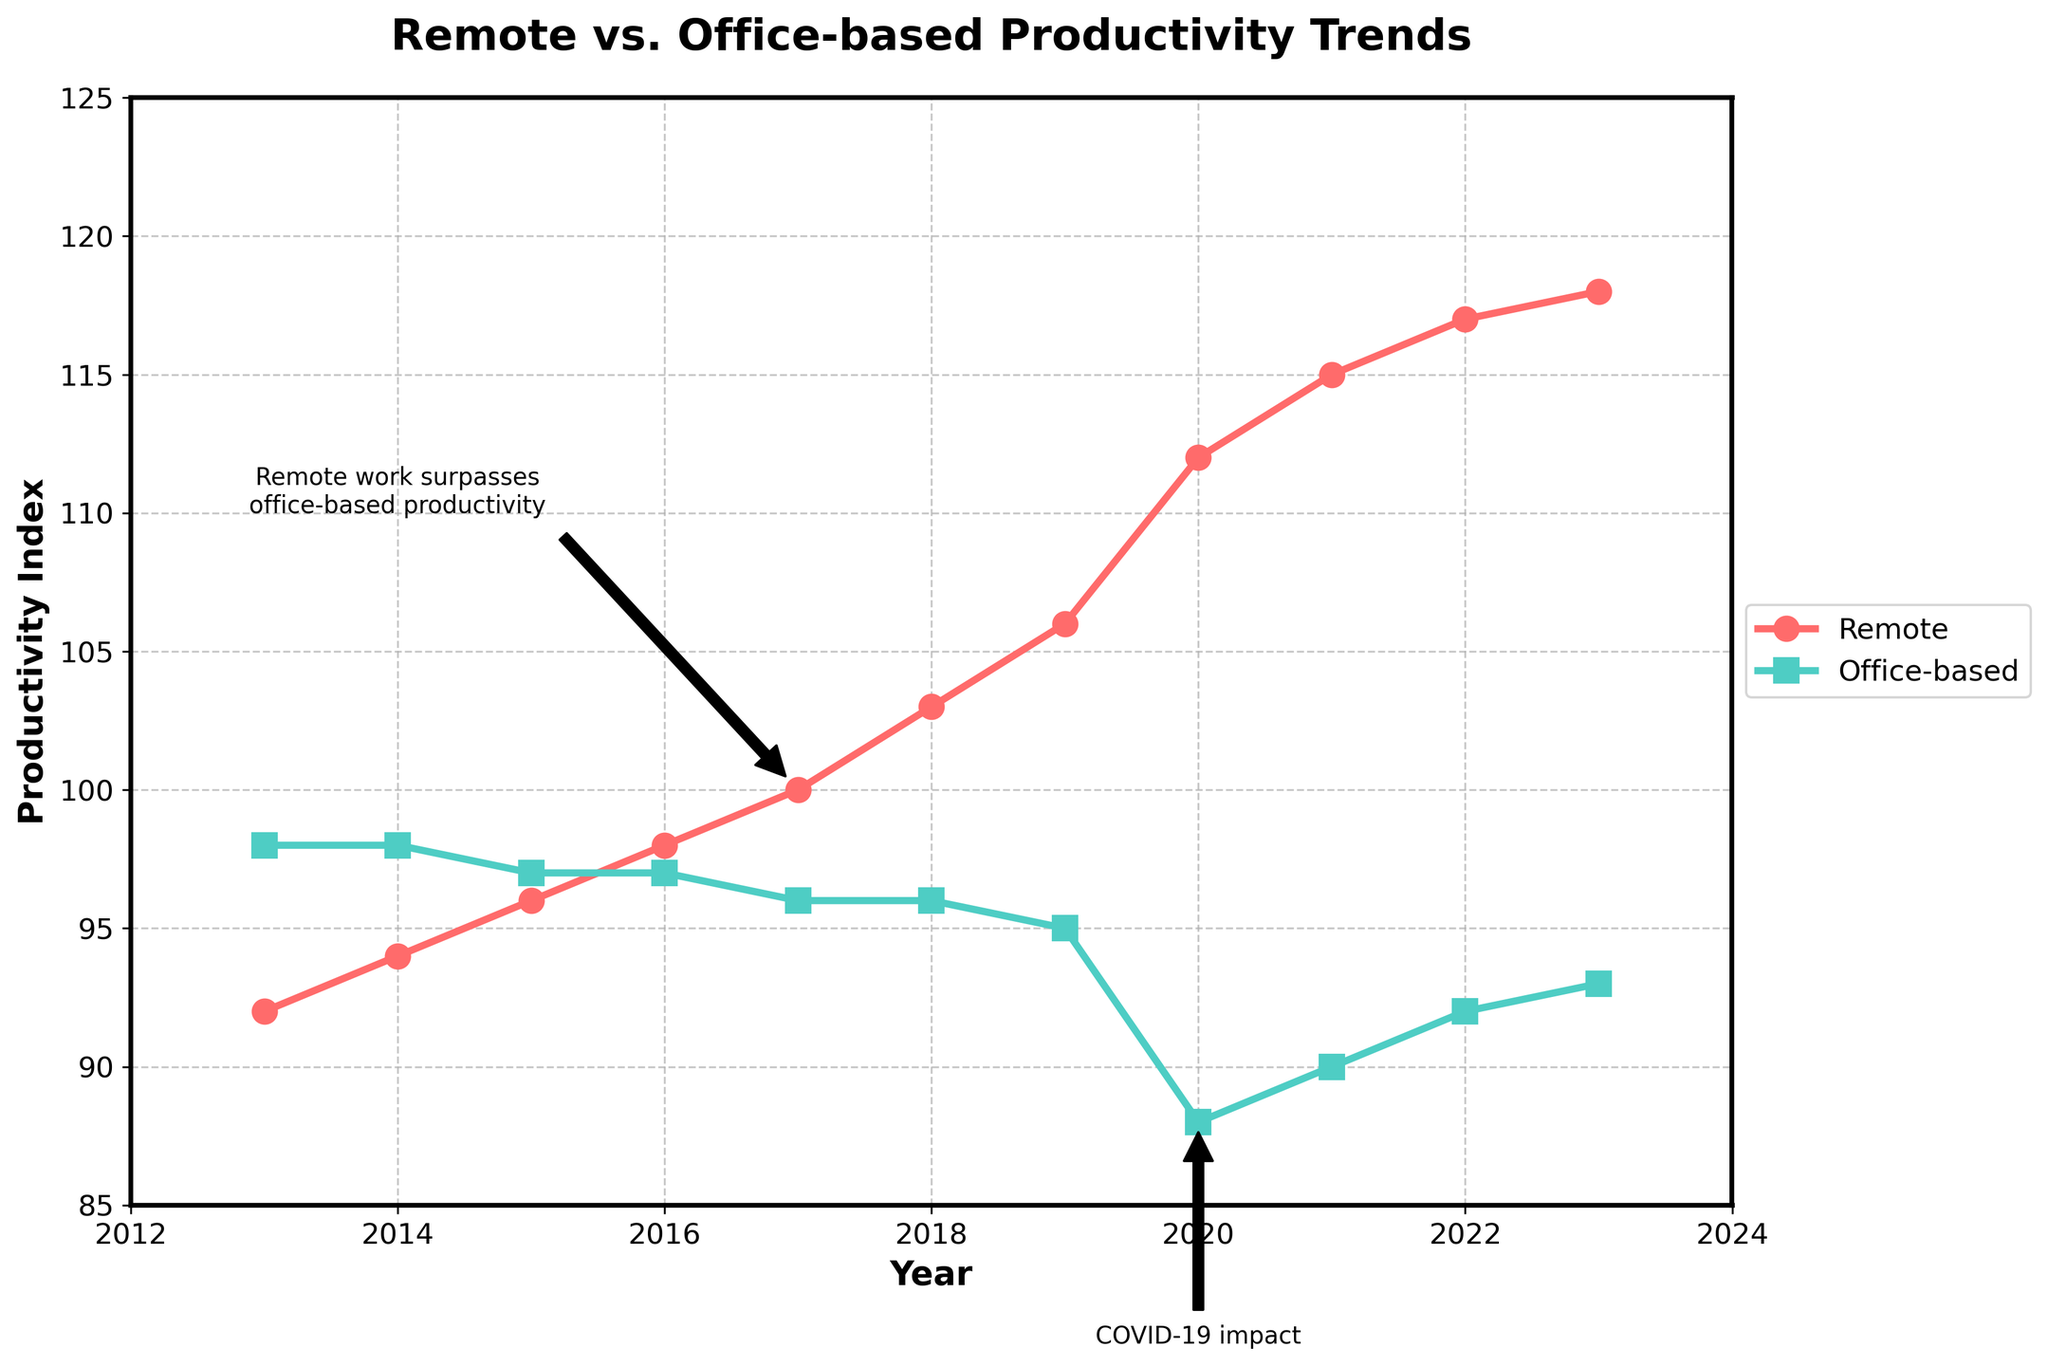What year did remote productivity first surpass office-based productivity? Remote productivity first surpassed office-based productivity in the year 2017, as indicated by the lines intersecting on the plot.
Answer: 2017 How much did the remote productivity index increase from 2013 to 2023? The remote productivity index in 2023 is 118, and in 2013 it was 92. The increase is 118 - 92 = 26 points.
Answer: 26 points Between which years did office-based productivity show a decline? By examining the trendline for office-based productivity, it can be seen that there is a decline from 2016 to 2020.
Answer: 2016 to 2020 What is the difference in productivity between remote and office-based work environments in 2020? In 2020, the remote productivity index is 112, while the office-based productivity index is 88. So, the difference is 112 - 88 = 24 points.
Answer: 24 points During which consecutive years did remote productivity see the largest increase? The largest increase in remote productivity occurred between 2019 and 2020, from 106 to 112, an increase of 6 points.
Answer: 2019 to 2020 How many years did office-based productivity maintain a steady index of 98? Office-based productivity maintained an index of 98 in the years 2013 and 2014.
Answer: 2 years Comparing the productivity index in 2019, which work environment had a higher index and by how much? In 2019, remote productivity had an index of 106, while office-based productivity had an index of 95. The difference is 106 - 95 = 11 points.
Answer: Remote, 11 points Which color represents the remote productivity line in the plot? The remote productivity line is represented by the red color.
Answer: Red According to the plot annotations, what significant event impacted office-based productivity around 2020? The annotation points to the 'COVID-19 impact' as a significant event affecting office-based productivity in 2020.
Answer: COVID-19 impact 